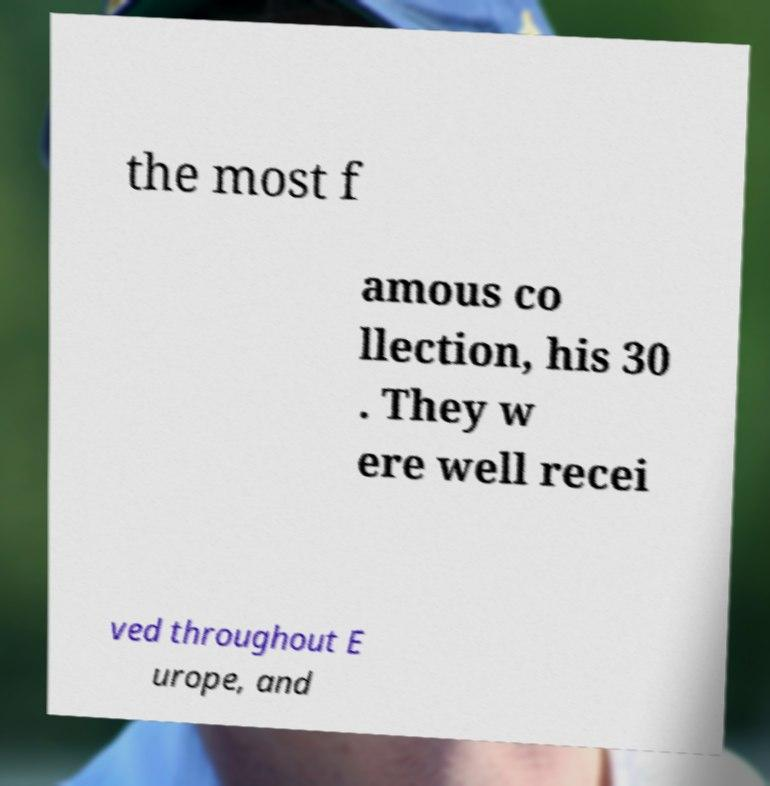I need the written content from this picture converted into text. Can you do that? the most f amous co llection, his 30 . They w ere well recei ved throughout E urope, and 